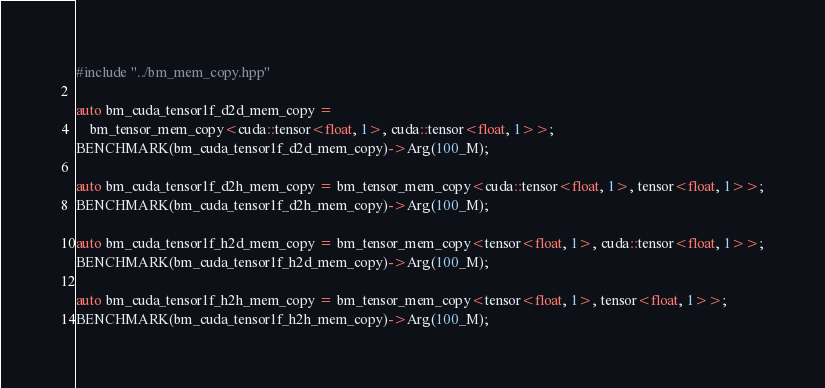<code> <loc_0><loc_0><loc_500><loc_500><_Cuda_>#include "../bm_mem_copy.hpp"

auto bm_cuda_tensor1f_d2d_mem_copy =
    bm_tensor_mem_copy<cuda::tensor<float, 1>, cuda::tensor<float, 1>>;
BENCHMARK(bm_cuda_tensor1f_d2d_mem_copy)->Arg(100_M);

auto bm_cuda_tensor1f_d2h_mem_copy = bm_tensor_mem_copy<cuda::tensor<float, 1>, tensor<float, 1>>;
BENCHMARK(bm_cuda_tensor1f_d2h_mem_copy)->Arg(100_M);

auto bm_cuda_tensor1f_h2d_mem_copy = bm_tensor_mem_copy<tensor<float, 1>, cuda::tensor<float, 1>>;
BENCHMARK(bm_cuda_tensor1f_h2d_mem_copy)->Arg(100_M);

auto bm_cuda_tensor1f_h2h_mem_copy = bm_tensor_mem_copy<tensor<float, 1>, tensor<float, 1>>;
BENCHMARK(bm_cuda_tensor1f_h2h_mem_copy)->Arg(100_M);</code> 